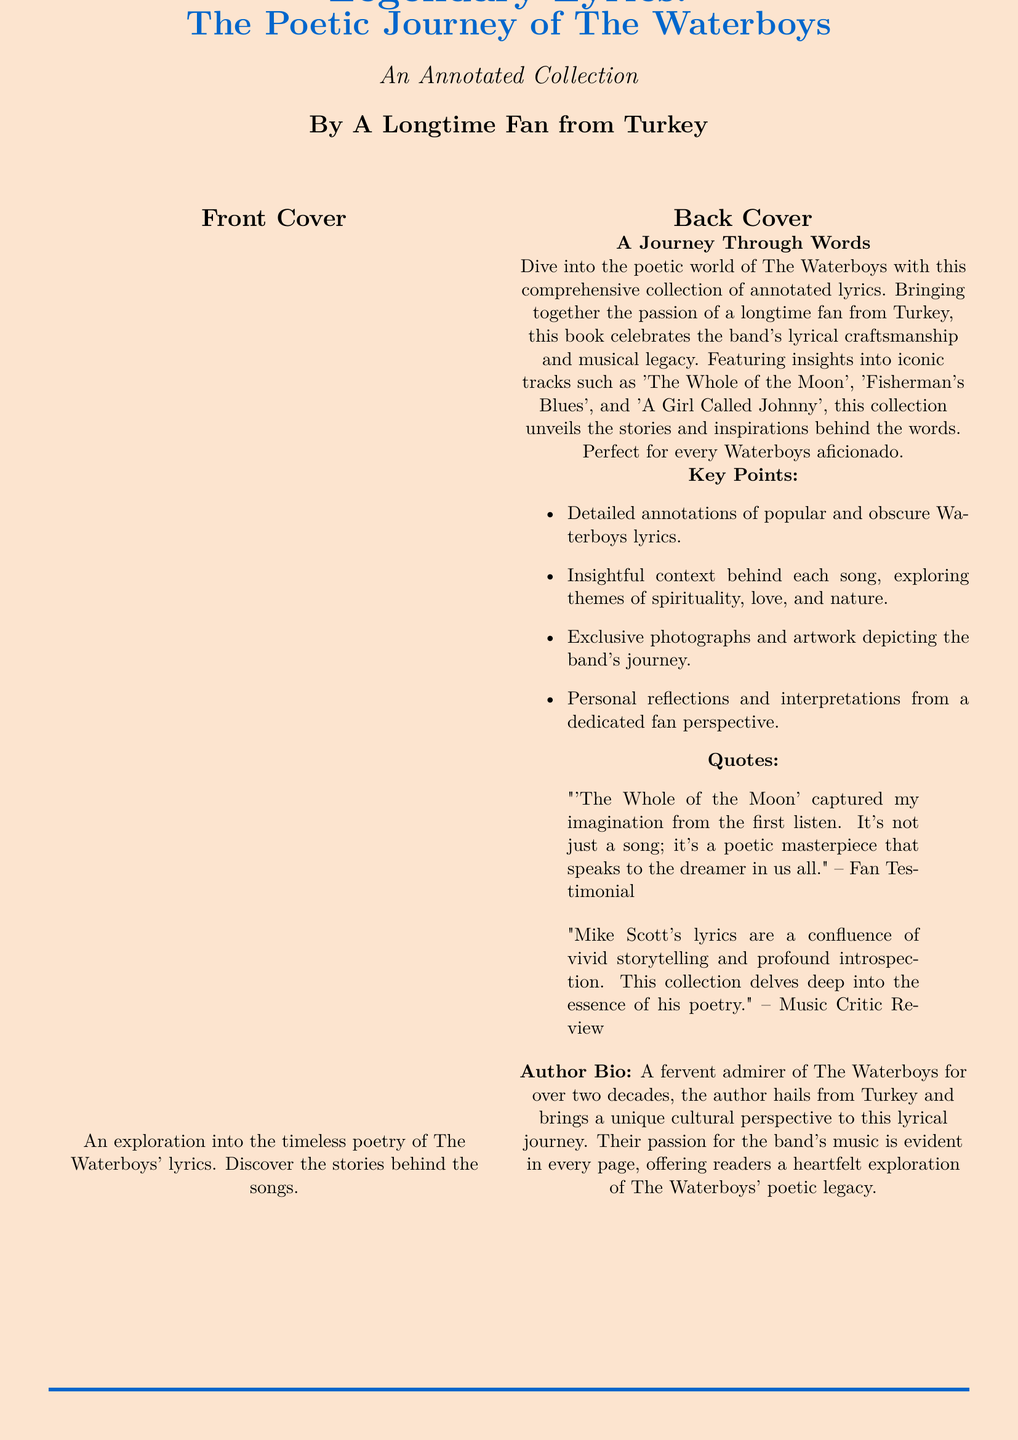What is the title of the book? The title can be found at the top of the cover, clearly stated.
Answer: Legendary Lyrics: The Poetic Journey of The Waterboys Who is the author of the book? The author's name is listed at the bottom of the cover.
Answer: A Longtime Fan from Turkey What type of book is this? The description specifies it is an annotated collection.
Answer: An Annotated Collection Which iconic track is mentioned first in the back cover description? The back cover lists iconic tracks, and the first one mentioned is noted.
Answer: The Whole of the Moon What themes are explored in the book? The back cover lists themes provided in the key points section.
Answer: Spirituality, love, and nature How long has the author been a fan of The Waterboys? The author bio specifies the duration of their admiration for the band.
Answer: Over two decades What is included in the collection besides lyrics? The key points mention additional content beside annotations of lyrics.
Answer: Exclusive photographs and artwork In what country is the author from? The author bio specifies the country of origin.
Answer: Turkey What color is the background of the cover? The document describes the background color used for the cover page.
Answer: Sandcolor 